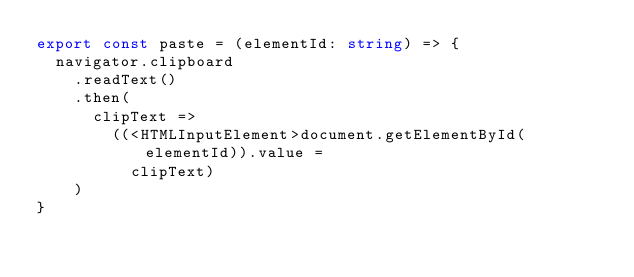Convert code to text. <code><loc_0><loc_0><loc_500><loc_500><_TypeScript_>export const paste = (elementId: string) => {
  navigator.clipboard
    .readText()
    .then(
      clipText =>
        ((<HTMLInputElement>document.getElementById(elementId)).value =
          clipText)
    )
}
</code> 